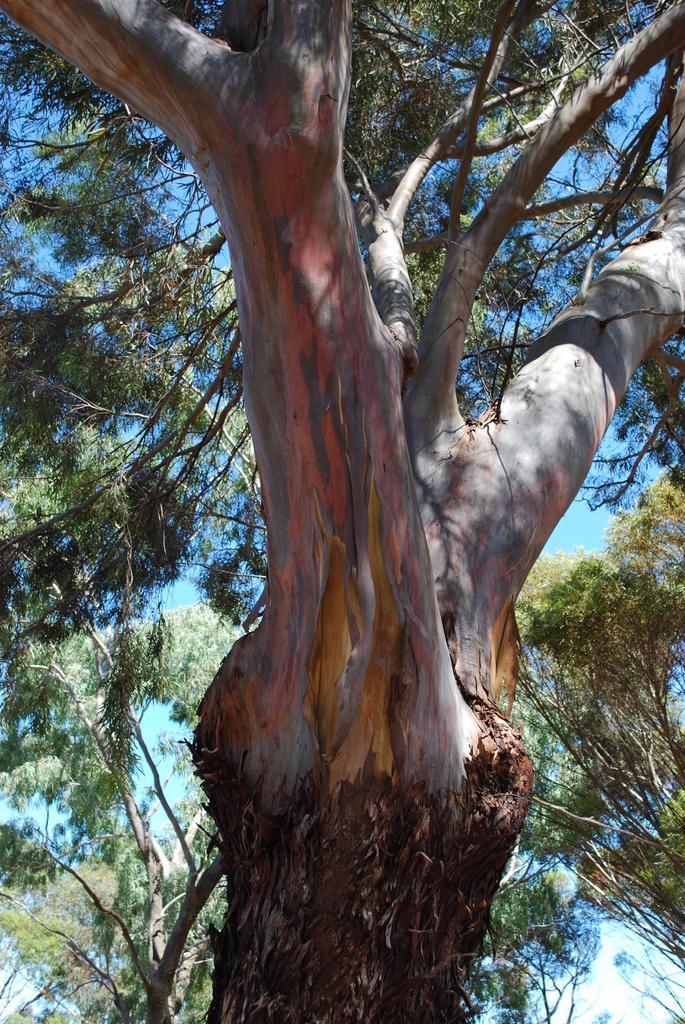Could you give a brief overview of what you see in this image? In this image we can see the branches of a tree with leaves. In the background, we can see a group of trees and the sky. 